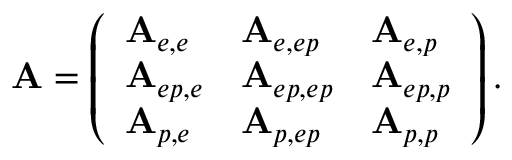<formula> <loc_0><loc_0><loc_500><loc_500>A = \left ( \begin{array} { l l l } { A _ { e , e } } & { A _ { e , e p } } & { A _ { e , p } } \\ { A _ { e p , e } } & { A _ { e p , e p } } & { A _ { e p , p } } \\ { A _ { p , e } } & { A _ { p , e p } } & { A _ { p , p } } \end{array} \right ) .</formula> 